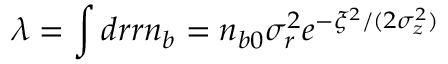<formula> <loc_0><loc_0><loc_500><loc_500>\lambda = \int d r r n _ { b } = n _ { b 0 } \sigma _ { r } ^ { 2 } e ^ { - \xi ^ { 2 } / ( 2 \sigma _ { z } ^ { 2 } ) }</formula> 